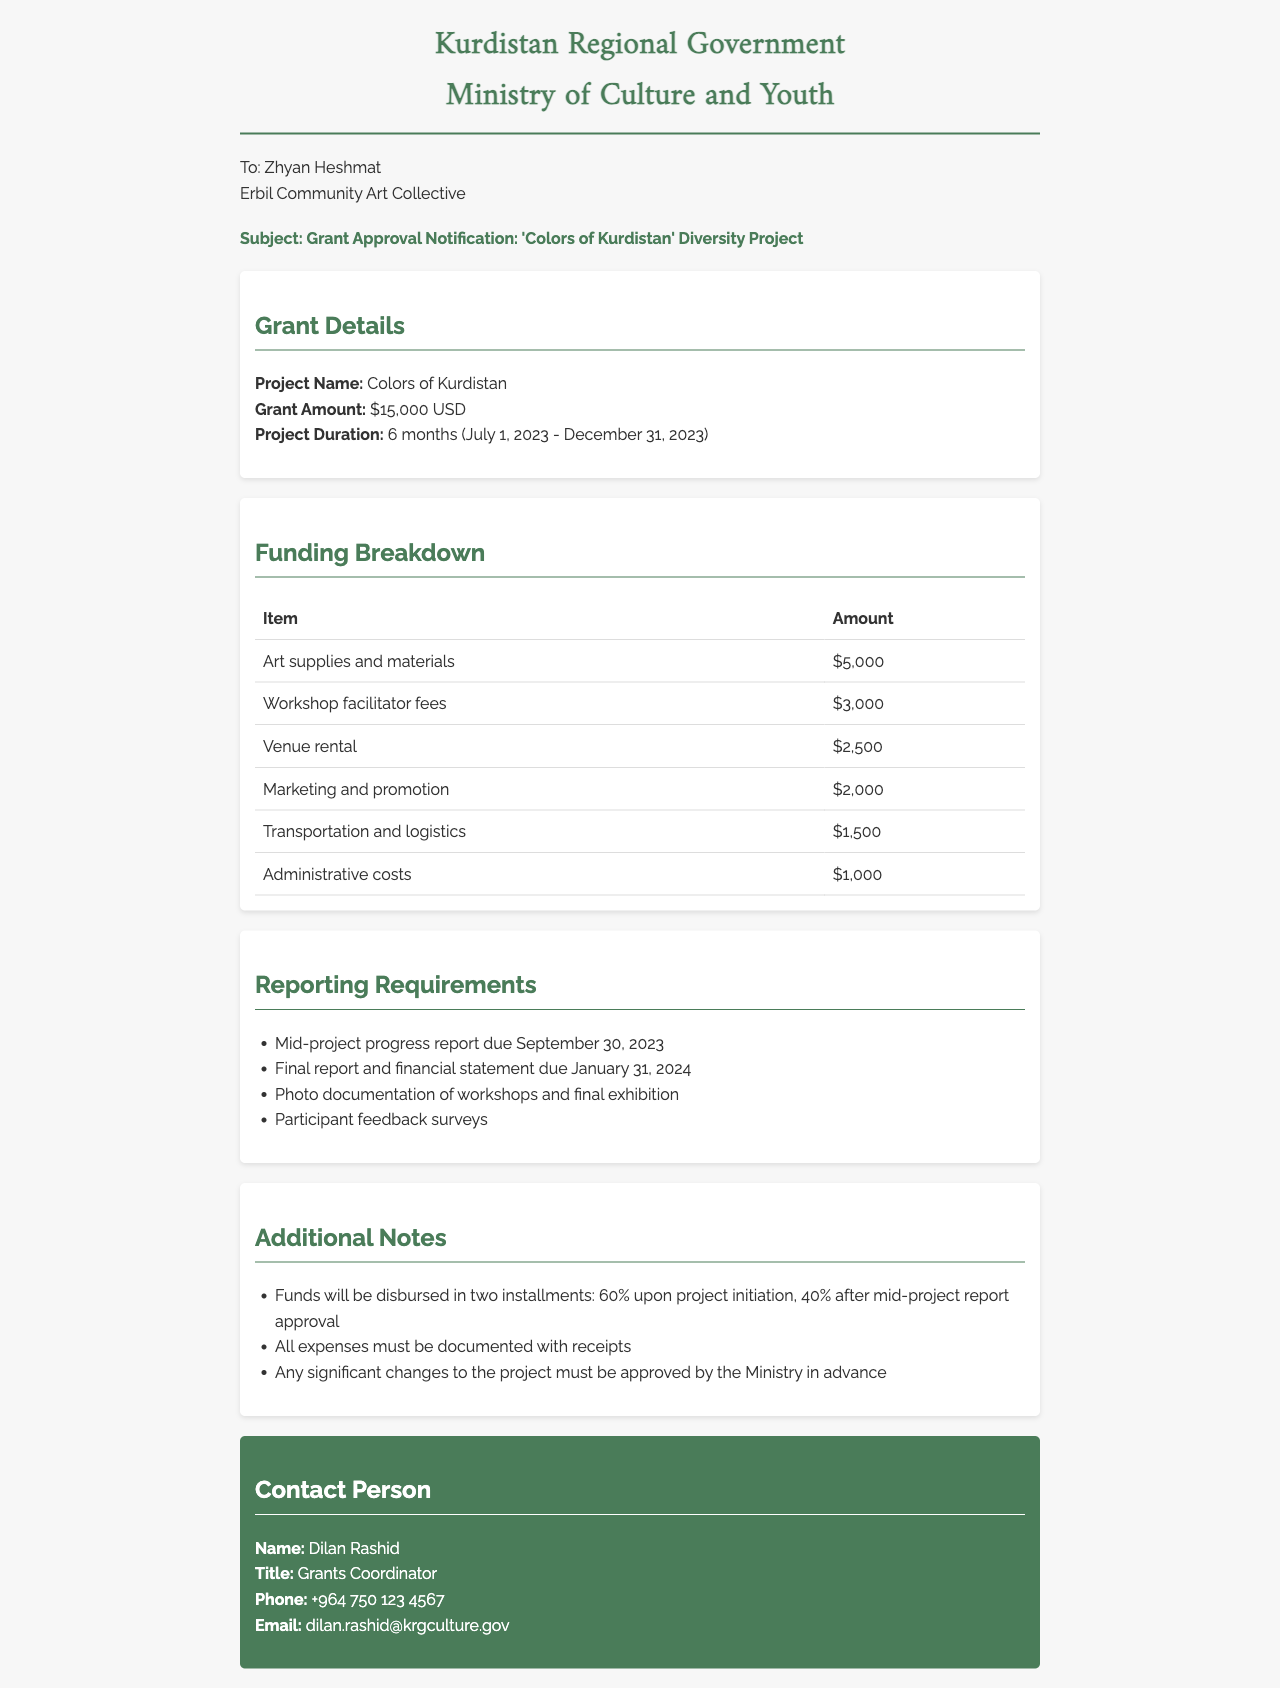What is the project name? The project name is mentioned clearly in the document as 'Colors of Kurdistan'.
Answer: Colors of Kurdistan What is the total grant amount? The total grant amount for the project is stated as $15,000 USD.
Answer: $15,000 USD What is the project duration? The project duration details are specified in the document, which lasts for 6 months from July 1, 2023, to December 31, 2023.
Answer: 6 months (July 1, 2023 - December 31, 2023) How much is allocated for art supplies? The breakdown shows that $5,000 is allocated specifically for art supplies and materials.
Answer: $5,000 When is the mid-project progress report due? The mid-project progress report is due on September 30, 2023, as listed in the reporting requirements.
Answer: September 30, 2023 How will funds be disbursed? The document indicates that funds will be disbursed in two installments, a specific percentage for each stage is mentioned.
Answer: 60% upon project initiation, 40% after mid-project report approval Who is the contact person for the grant? The document specifies that Dilan Rashid is the contact person for the grant.
Answer: Dilan Rashid What is required for final reporting? The final report and financial statement must be submitted, along with photo documentation and participant feedback surveys.
Answer: Final report and financial statement How much is allocated for marketing and promotion? The funding breakdown includes an allocation of $2,000 for marketing and promotion.
Answer: $2,000 